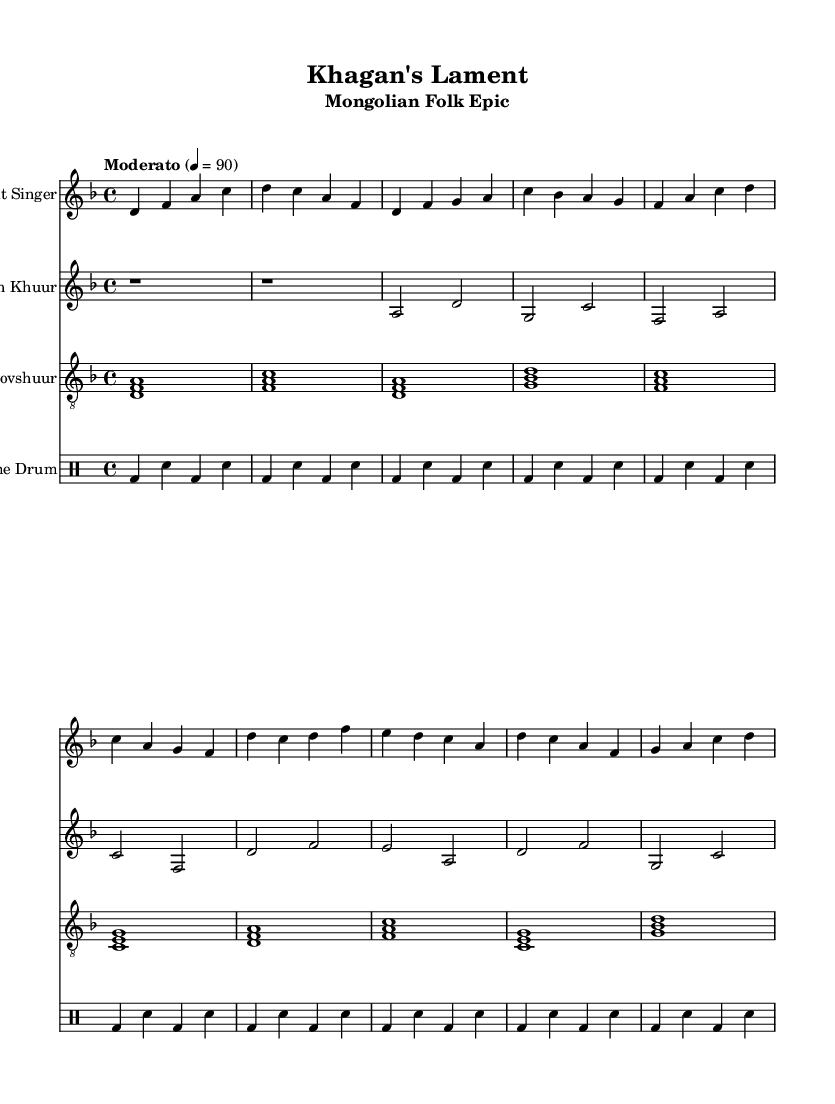What is the key signature of this music? The key signature is indicated at the beginning of the piece. The presence of a flat indicates D minor, which has one flat (B flat).
Answer: D minor What is the time signature of this music? The time signature is located at the beginning of the score and specifies the number of beats in each measure. It shows 4 beats per measure, which is typical for many folk tunes.
Answer: 4/4 What is the tempo marking of this piece? The tempo marking is found in the header section of the score, indicated as "Moderato," which signifies a moderate pace.
Answer: Moderato How many staves are there in the score? Upon examining the score sections, we see there are four distinct staves: one for the throat singer, one for the morin khuur, one for the tovshuur, and one for the frame drum.
Answer: Four In which section does the chorus begin? The chorus can be identified in the score by analyzing the lyric structure. It begins after the first verse, indicated by a change in the music flow and typically reflected in the notation.
Answer: After Verse 1 Which instrument plays the introduction? The introduction is written in the first part of the score; by observing the staves, the throat singer's notes are the first to appear, indicating they introduce the piece.
Answer: Throat Singer What is the role of the frame drum in this composition? The frame drum serves a rhythmic purpose as seen in the drummode section, where the sequence of notes reflects a consistent beat that supports the melody.
Answer: Rhythmic support 